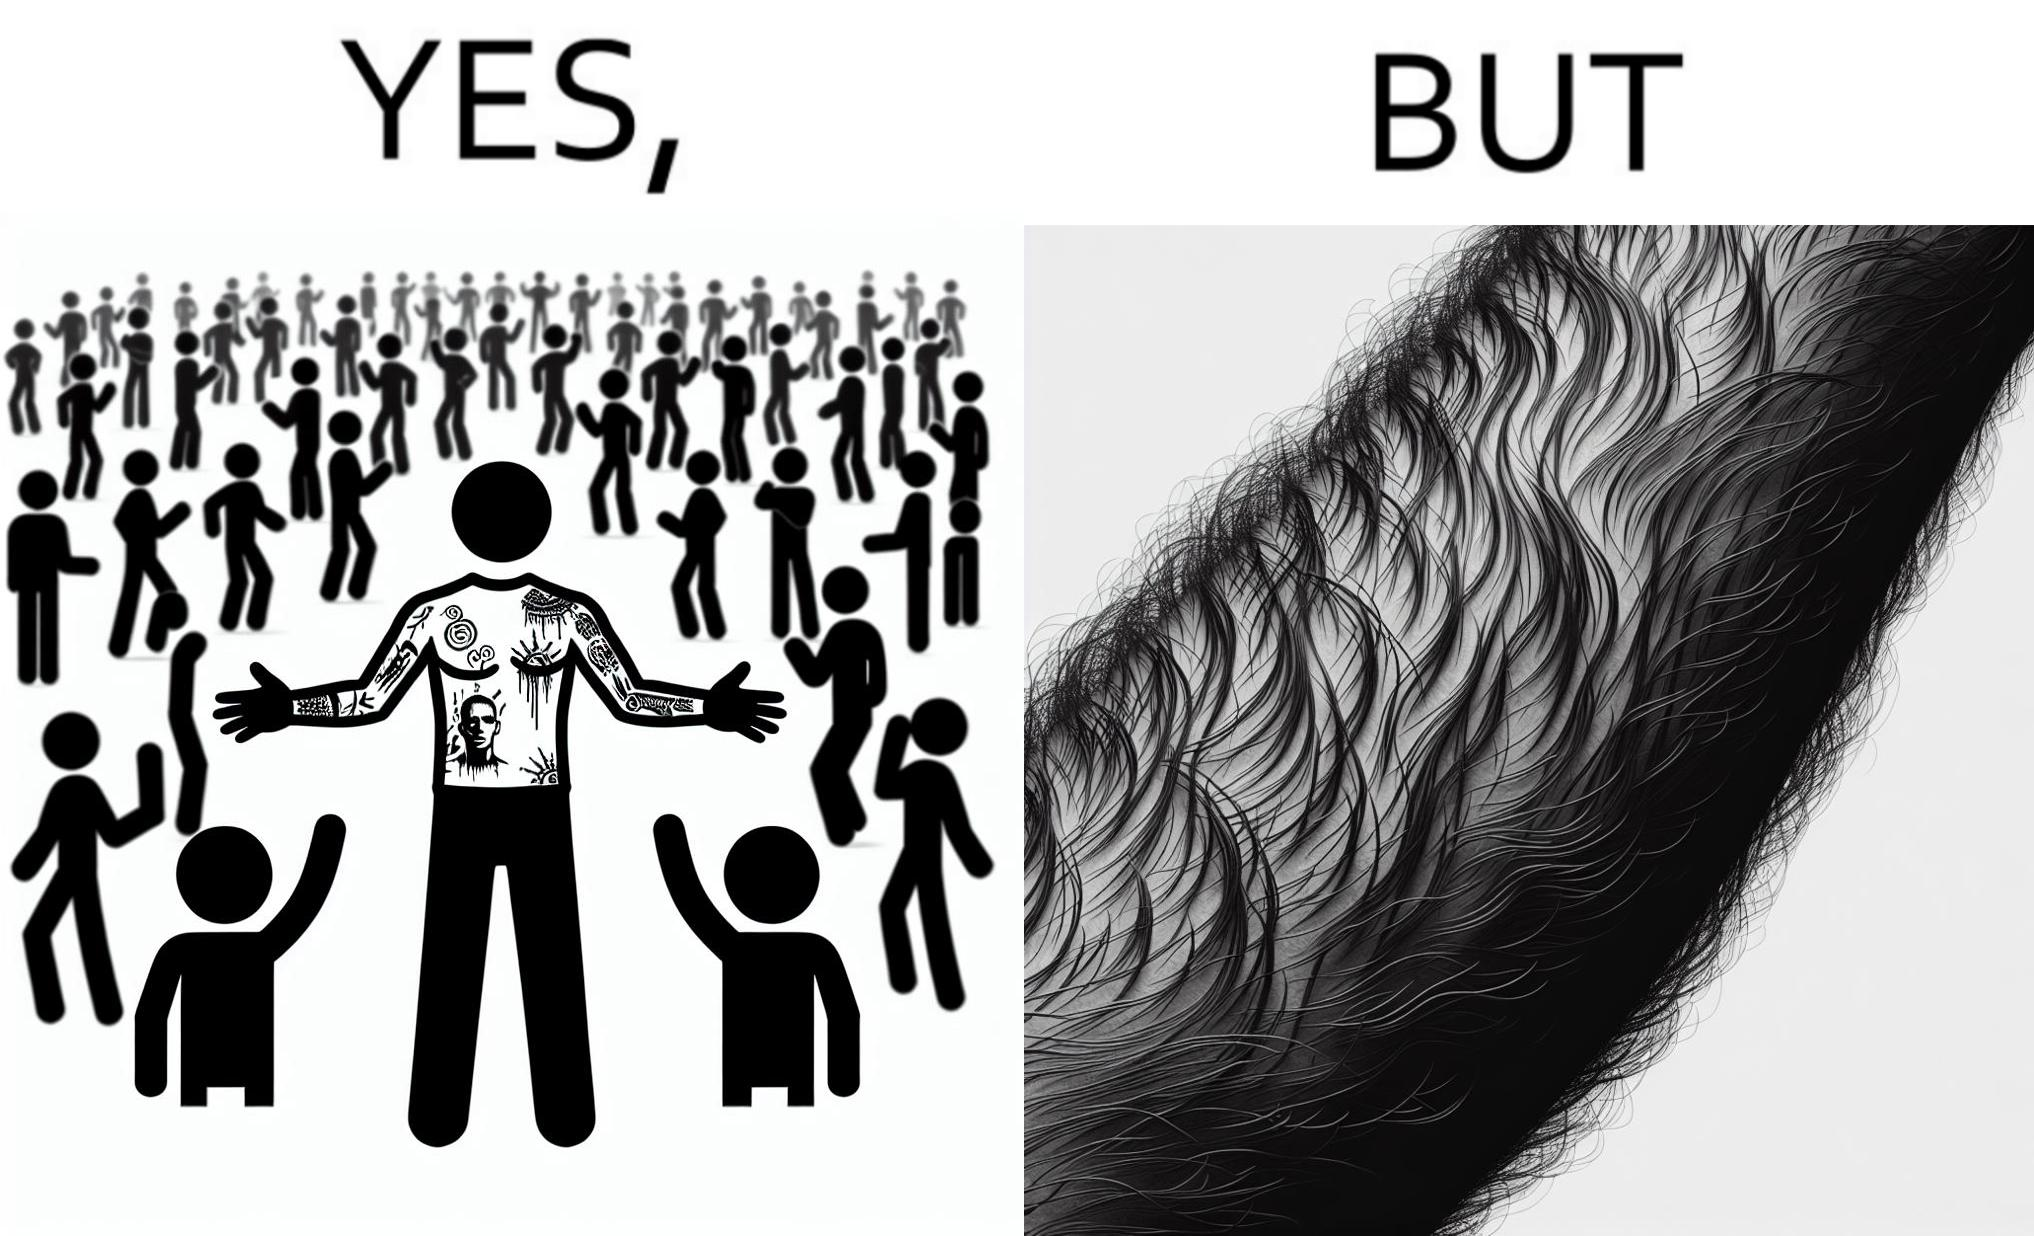Explain why this image is satirical. The image is funny because while from the distance it seems that the man has big tattoos on both of his arms upon a closer look at the arms it turns out there is no tattoo and what seemed to be tattoos are just hairs on his arm. 